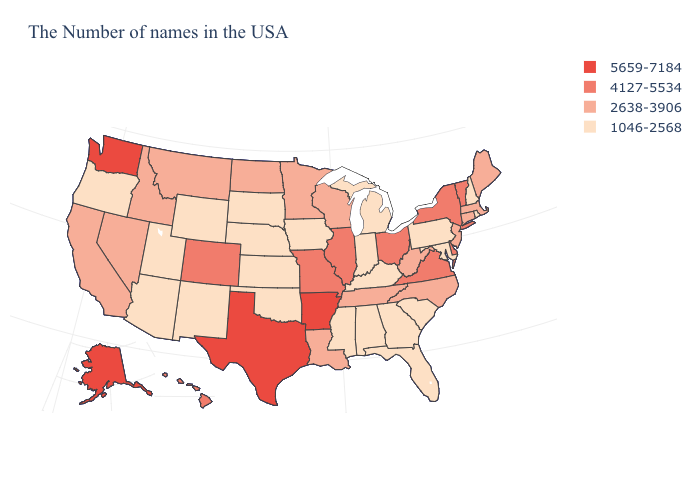Name the states that have a value in the range 1046-2568?
Write a very short answer. Rhode Island, New Hampshire, Maryland, Pennsylvania, South Carolina, Florida, Georgia, Michigan, Kentucky, Indiana, Alabama, Mississippi, Iowa, Kansas, Nebraska, Oklahoma, South Dakota, Wyoming, New Mexico, Utah, Arizona, Oregon. What is the value of Washington?
Write a very short answer. 5659-7184. What is the value of Kansas?
Give a very brief answer. 1046-2568. Among the states that border North Carolina , which have the lowest value?
Write a very short answer. South Carolina, Georgia. Does the first symbol in the legend represent the smallest category?
Concise answer only. No. Does Kansas have the lowest value in the MidWest?
Concise answer only. Yes. What is the value of Missouri?
Write a very short answer. 4127-5534. What is the value of North Carolina?
Quick response, please. 2638-3906. What is the lowest value in states that border Ohio?
Give a very brief answer. 1046-2568. Name the states that have a value in the range 1046-2568?
Give a very brief answer. Rhode Island, New Hampshire, Maryland, Pennsylvania, South Carolina, Florida, Georgia, Michigan, Kentucky, Indiana, Alabama, Mississippi, Iowa, Kansas, Nebraska, Oklahoma, South Dakota, Wyoming, New Mexico, Utah, Arizona, Oregon. Which states hav the highest value in the West?
Quick response, please. Washington, Alaska. Name the states that have a value in the range 5659-7184?
Be succinct. Arkansas, Texas, Washington, Alaska. Name the states that have a value in the range 1046-2568?
Short answer required. Rhode Island, New Hampshire, Maryland, Pennsylvania, South Carolina, Florida, Georgia, Michigan, Kentucky, Indiana, Alabama, Mississippi, Iowa, Kansas, Nebraska, Oklahoma, South Dakota, Wyoming, New Mexico, Utah, Arizona, Oregon. Name the states that have a value in the range 1046-2568?
Write a very short answer. Rhode Island, New Hampshire, Maryland, Pennsylvania, South Carolina, Florida, Georgia, Michigan, Kentucky, Indiana, Alabama, Mississippi, Iowa, Kansas, Nebraska, Oklahoma, South Dakota, Wyoming, New Mexico, Utah, Arizona, Oregon. 